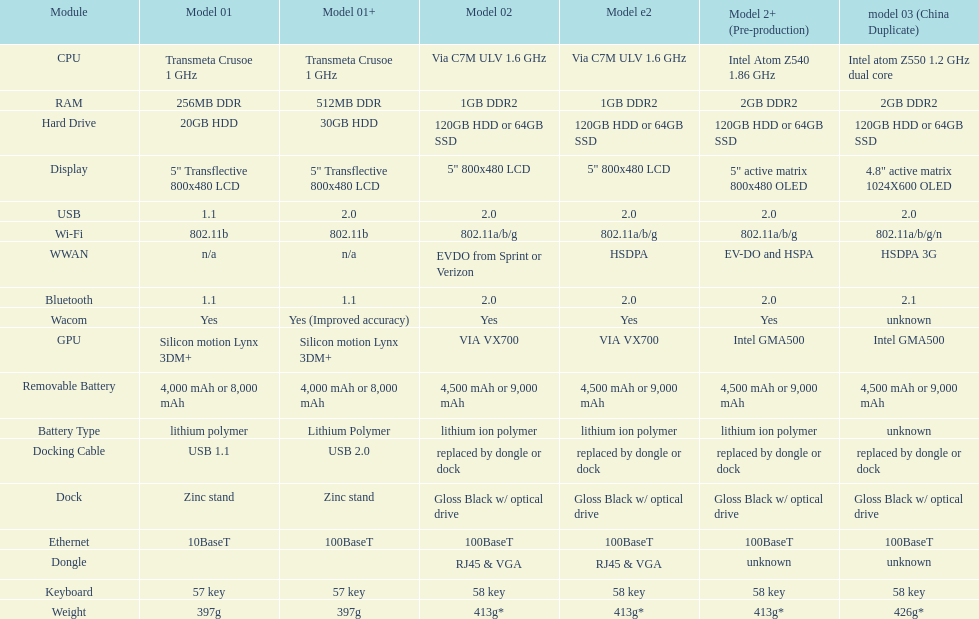The model 2 and the model 2e have what type of cpu? Via C7M ULV 1.6 GHz. 